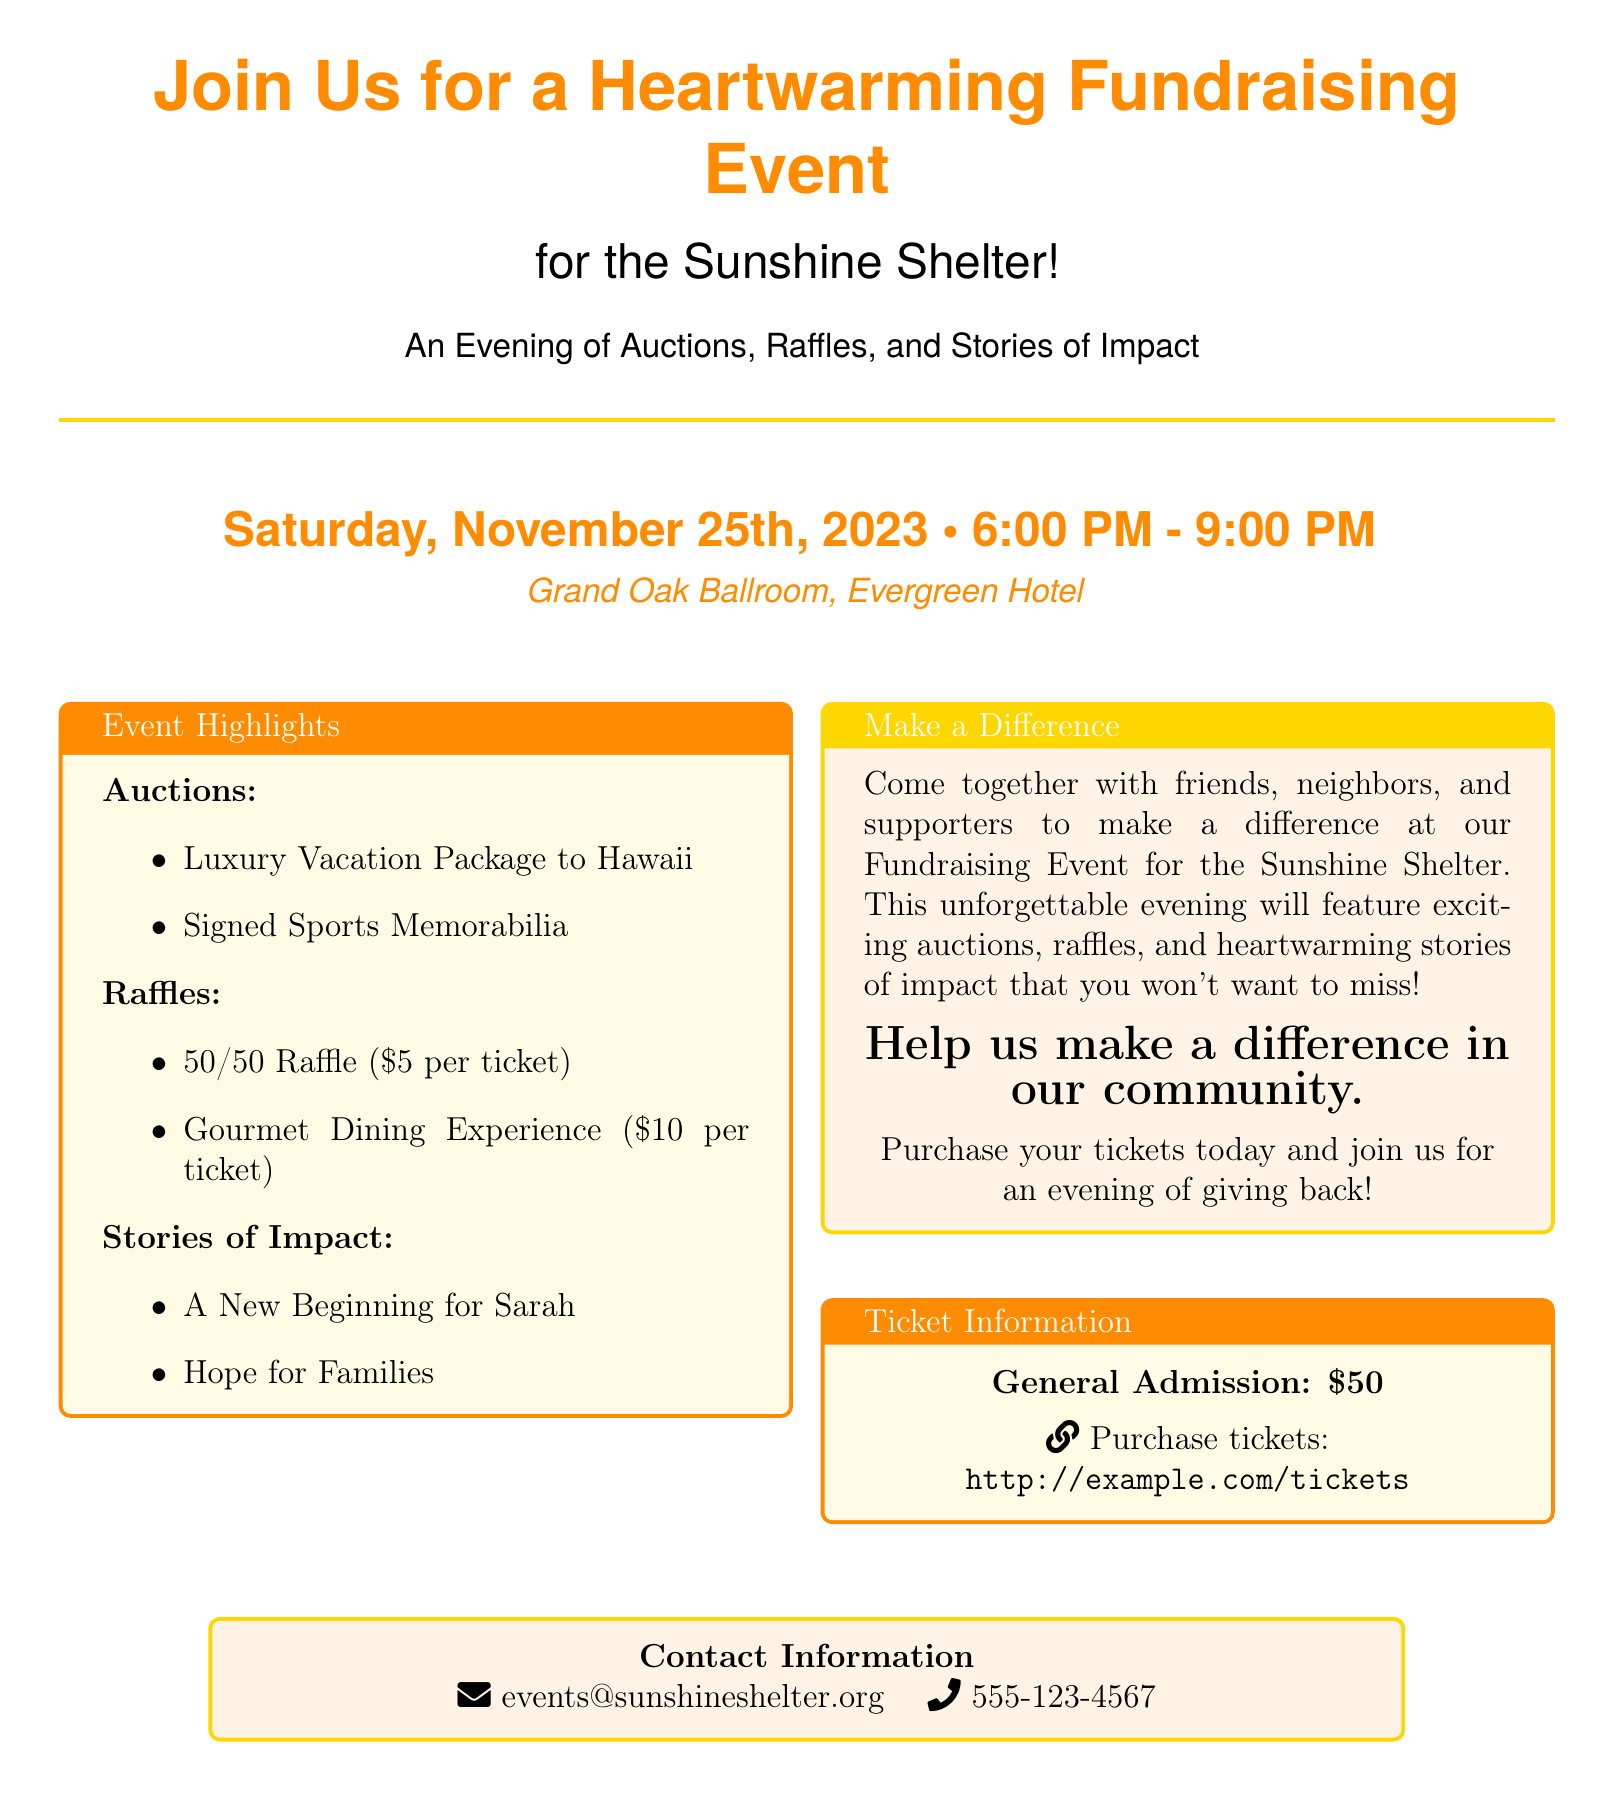What is the date of the event? The date is mentioned clearly in the document, indicating when the fundraising event will take place.
Answer: November 25th, 2023 What is the location of the event? The document specifies the venue for the fundraising event, making it easy to find.
Answer: Grand Oak Ballroom, Evergreen Hotel What is the ticket price for general admission? The ticket information section provides the cost for attending the event.
Answer: $50 What time does the event start? The document lists the starting time of the fundraising event, which is important for attendees.
Answer: 6:00 PM What is one of the auction items? The event highlights section lists specific items that will be available for auction.
Answer: Luxury Vacation Package to Hawaii What are the prices for raffle tickets? The raffle section details the costs of participating in different raffle opportunities.
Answer: $5 per ticket, $10 per ticket How long is the fundraising event scheduled to last? The event duration is indicated by the start and end times provided in the document.
Answer: 3 hours What type of stories will be shared during the event? The document mentions the themes of the stories that will be featured, which are meant to inspire.
Answer: Stories of Impact 